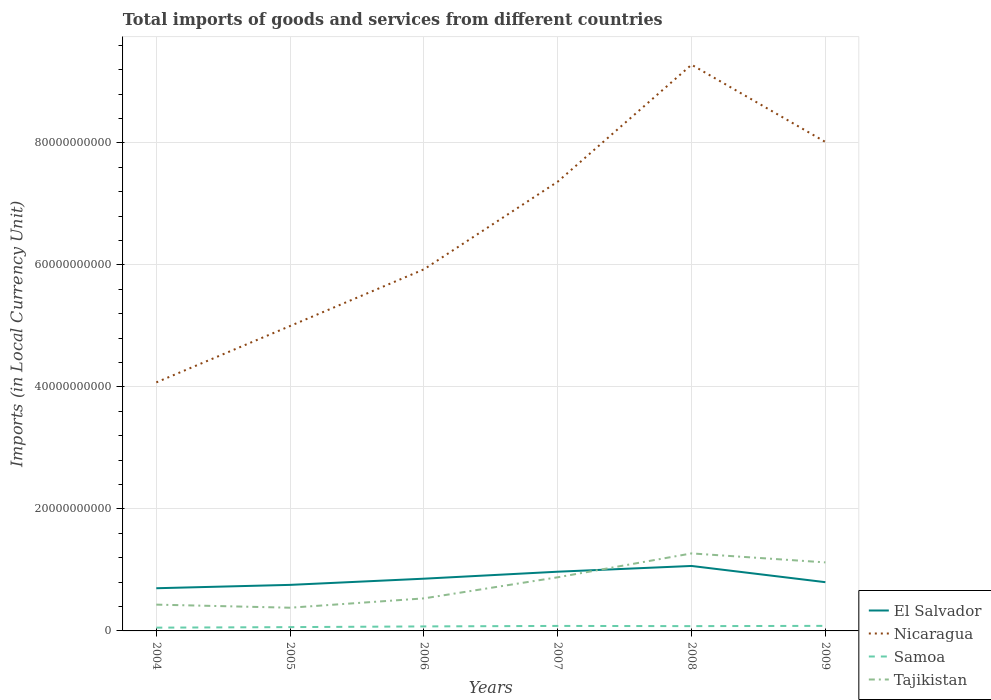How many different coloured lines are there?
Your answer should be very brief. 4. Does the line corresponding to El Salvador intersect with the line corresponding to Samoa?
Your answer should be compact. No. Across all years, what is the maximum Amount of goods and services imports in Nicaragua?
Keep it short and to the point. 4.07e+1. What is the total Amount of goods and services imports in Nicaragua in the graph?
Your response must be concise. -3.29e+1. What is the difference between the highest and the second highest Amount of goods and services imports in Samoa?
Offer a terse response. 2.92e+08. Is the Amount of goods and services imports in Samoa strictly greater than the Amount of goods and services imports in El Salvador over the years?
Give a very brief answer. Yes. What is the difference between two consecutive major ticks on the Y-axis?
Give a very brief answer. 2.00e+1. Does the graph contain any zero values?
Provide a short and direct response. No. How many legend labels are there?
Provide a short and direct response. 4. How are the legend labels stacked?
Keep it short and to the point. Vertical. What is the title of the graph?
Keep it short and to the point. Total imports of goods and services from different countries. What is the label or title of the Y-axis?
Ensure brevity in your answer.  Imports (in Local Currency Unit). What is the Imports (in Local Currency Unit) in El Salvador in 2004?
Make the answer very short. 7.00e+09. What is the Imports (in Local Currency Unit) in Nicaragua in 2004?
Your answer should be compact. 4.07e+1. What is the Imports (in Local Currency Unit) in Samoa in 2004?
Your answer should be very brief. 5.37e+08. What is the Imports (in Local Currency Unit) in Tajikistan in 2004?
Offer a very short reply. 4.31e+09. What is the Imports (in Local Currency Unit) in El Salvador in 2005?
Make the answer very short. 7.55e+09. What is the Imports (in Local Currency Unit) in Nicaragua in 2005?
Ensure brevity in your answer.  5.00e+1. What is the Imports (in Local Currency Unit) of Samoa in 2005?
Keep it short and to the point. 6.23e+08. What is the Imports (in Local Currency Unit) in Tajikistan in 2005?
Give a very brief answer. 3.81e+09. What is the Imports (in Local Currency Unit) of El Salvador in 2006?
Your answer should be very brief. 8.56e+09. What is the Imports (in Local Currency Unit) of Nicaragua in 2006?
Provide a succinct answer. 5.93e+1. What is the Imports (in Local Currency Unit) of Samoa in 2006?
Give a very brief answer. 7.39e+08. What is the Imports (in Local Currency Unit) of Tajikistan in 2006?
Make the answer very short. 5.34e+09. What is the Imports (in Local Currency Unit) of El Salvador in 2007?
Offer a very short reply. 9.71e+09. What is the Imports (in Local Currency Unit) in Nicaragua in 2007?
Keep it short and to the point. 7.37e+1. What is the Imports (in Local Currency Unit) in Samoa in 2007?
Offer a very short reply. 8.20e+08. What is the Imports (in Local Currency Unit) of Tajikistan in 2007?
Provide a succinct answer. 8.79e+09. What is the Imports (in Local Currency Unit) in El Salvador in 2008?
Give a very brief answer. 1.07e+1. What is the Imports (in Local Currency Unit) of Nicaragua in 2008?
Your answer should be very brief. 9.28e+1. What is the Imports (in Local Currency Unit) of Samoa in 2008?
Provide a short and direct response. 7.86e+08. What is the Imports (in Local Currency Unit) in Tajikistan in 2008?
Give a very brief answer. 1.27e+1. What is the Imports (in Local Currency Unit) in El Salvador in 2009?
Keep it short and to the point. 7.99e+09. What is the Imports (in Local Currency Unit) in Nicaragua in 2009?
Your response must be concise. 8.02e+1. What is the Imports (in Local Currency Unit) of Samoa in 2009?
Offer a terse response. 8.29e+08. What is the Imports (in Local Currency Unit) of Tajikistan in 2009?
Keep it short and to the point. 1.12e+1. Across all years, what is the maximum Imports (in Local Currency Unit) of El Salvador?
Keep it short and to the point. 1.07e+1. Across all years, what is the maximum Imports (in Local Currency Unit) of Nicaragua?
Offer a very short reply. 9.28e+1. Across all years, what is the maximum Imports (in Local Currency Unit) of Samoa?
Offer a very short reply. 8.29e+08. Across all years, what is the maximum Imports (in Local Currency Unit) in Tajikistan?
Keep it short and to the point. 1.27e+1. Across all years, what is the minimum Imports (in Local Currency Unit) of El Salvador?
Ensure brevity in your answer.  7.00e+09. Across all years, what is the minimum Imports (in Local Currency Unit) in Nicaragua?
Ensure brevity in your answer.  4.07e+1. Across all years, what is the minimum Imports (in Local Currency Unit) in Samoa?
Offer a terse response. 5.37e+08. Across all years, what is the minimum Imports (in Local Currency Unit) in Tajikistan?
Your answer should be compact. 3.81e+09. What is the total Imports (in Local Currency Unit) of El Salvador in the graph?
Make the answer very short. 5.15e+1. What is the total Imports (in Local Currency Unit) in Nicaragua in the graph?
Offer a terse response. 3.97e+11. What is the total Imports (in Local Currency Unit) of Samoa in the graph?
Provide a short and direct response. 4.33e+09. What is the total Imports (in Local Currency Unit) in Tajikistan in the graph?
Offer a very short reply. 4.62e+1. What is the difference between the Imports (in Local Currency Unit) in El Salvador in 2004 and that in 2005?
Make the answer very short. -5.51e+08. What is the difference between the Imports (in Local Currency Unit) of Nicaragua in 2004 and that in 2005?
Make the answer very short. -9.25e+09. What is the difference between the Imports (in Local Currency Unit) of Samoa in 2004 and that in 2005?
Ensure brevity in your answer.  -8.63e+07. What is the difference between the Imports (in Local Currency Unit) of Tajikistan in 2004 and that in 2005?
Keep it short and to the point. 5.06e+08. What is the difference between the Imports (in Local Currency Unit) of El Salvador in 2004 and that in 2006?
Make the answer very short. -1.57e+09. What is the difference between the Imports (in Local Currency Unit) in Nicaragua in 2004 and that in 2006?
Offer a terse response. -1.85e+1. What is the difference between the Imports (in Local Currency Unit) in Samoa in 2004 and that in 2006?
Ensure brevity in your answer.  -2.02e+08. What is the difference between the Imports (in Local Currency Unit) in Tajikistan in 2004 and that in 2006?
Your response must be concise. -1.02e+09. What is the difference between the Imports (in Local Currency Unit) in El Salvador in 2004 and that in 2007?
Make the answer very short. -2.71e+09. What is the difference between the Imports (in Local Currency Unit) of Nicaragua in 2004 and that in 2007?
Give a very brief answer. -3.29e+1. What is the difference between the Imports (in Local Currency Unit) in Samoa in 2004 and that in 2007?
Your answer should be very brief. -2.83e+08. What is the difference between the Imports (in Local Currency Unit) in Tajikistan in 2004 and that in 2007?
Make the answer very short. -4.48e+09. What is the difference between the Imports (in Local Currency Unit) of El Salvador in 2004 and that in 2008?
Provide a succinct answer. -3.65e+09. What is the difference between the Imports (in Local Currency Unit) in Nicaragua in 2004 and that in 2008?
Give a very brief answer. -5.21e+1. What is the difference between the Imports (in Local Currency Unit) of Samoa in 2004 and that in 2008?
Offer a terse response. -2.49e+08. What is the difference between the Imports (in Local Currency Unit) in Tajikistan in 2004 and that in 2008?
Provide a short and direct response. -8.40e+09. What is the difference between the Imports (in Local Currency Unit) of El Salvador in 2004 and that in 2009?
Provide a succinct answer. -9.92e+08. What is the difference between the Imports (in Local Currency Unit) of Nicaragua in 2004 and that in 2009?
Your answer should be very brief. -3.94e+1. What is the difference between the Imports (in Local Currency Unit) of Samoa in 2004 and that in 2009?
Provide a succinct answer. -2.92e+08. What is the difference between the Imports (in Local Currency Unit) in Tajikistan in 2004 and that in 2009?
Make the answer very short. -6.92e+09. What is the difference between the Imports (in Local Currency Unit) of El Salvador in 2005 and that in 2006?
Your answer should be compact. -1.02e+09. What is the difference between the Imports (in Local Currency Unit) of Nicaragua in 2005 and that in 2006?
Provide a short and direct response. -9.29e+09. What is the difference between the Imports (in Local Currency Unit) of Samoa in 2005 and that in 2006?
Your response must be concise. -1.16e+08. What is the difference between the Imports (in Local Currency Unit) in Tajikistan in 2005 and that in 2006?
Offer a very short reply. -1.53e+09. What is the difference between the Imports (in Local Currency Unit) of El Salvador in 2005 and that in 2007?
Make the answer very short. -2.16e+09. What is the difference between the Imports (in Local Currency Unit) in Nicaragua in 2005 and that in 2007?
Your answer should be compact. -2.37e+1. What is the difference between the Imports (in Local Currency Unit) of Samoa in 2005 and that in 2007?
Keep it short and to the point. -1.97e+08. What is the difference between the Imports (in Local Currency Unit) in Tajikistan in 2005 and that in 2007?
Provide a succinct answer. -4.99e+09. What is the difference between the Imports (in Local Currency Unit) in El Salvador in 2005 and that in 2008?
Offer a very short reply. -3.10e+09. What is the difference between the Imports (in Local Currency Unit) in Nicaragua in 2005 and that in 2008?
Ensure brevity in your answer.  -4.28e+1. What is the difference between the Imports (in Local Currency Unit) of Samoa in 2005 and that in 2008?
Give a very brief answer. -1.63e+08. What is the difference between the Imports (in Local Currency Unit) in Tajikistan in 2005 and that in 2008?
Provide a succinct answer. -8.90e+09. What is the difference between the Imports (in Local Currency Unit) in El Salvador in 2005 and that in 2009?
Your answer should be compact. -4.42e+08. What is the difference between the Imports (in Local Currency Unit) in Nicaragua in 2005 and that in 2009?
Ensure brevity in your answer.  -3.02e+1. What is the difference between the Imports (in Local Currency Unit) in Samoa in 2005 and that in 2009?
Your answer should be compact. -2.06e+08. What is the difference between the Imports (in Local Currency Unit) of Tajikistan in 2005 and that in 2009?
Your answer should be very brief. -7.43e+09. What is the difference between the Imports (in Local Currency Unit) in El Salvador in 2006 and that in 2007?
Ensure brevity in your answer.  -1.15e+09. What is the difference between the Imports (in Local Currency Unit) in Nicaragua in 2006 and that in 2007?
Keep it short and to the point. -1.44e+1. What is the difference between the Imports (in Local Currency Unit) in Samoa in 2006 and that in 2007?
Make the answer very short. -8.07e+07. What is the difference between the Imports (in Local Currency Unit) in Tajikistan in 2006 and that in 2007?
Offer a terse response. -3.46e+09. What is the difference between the Imports (in Local Currency Unit) in El Salvador in 2006 and that in 2008?
Provide a succinct answer. -2.09e+09. What is the difference between the Imports (in Local Currency Unit) in Nicaragua in 2006 and that in 2008?
Your answer should be compact. -3.35e+1. What is the difference between the Imports (in Local Currency Unit) of Samoa in 2006 and that in 2008?
Ensure brevity in your answer.  -4.67e+07. What is the difference between the Imports (in Local Currency Unit) in Tajikistan in 2006 and that in 2008?
Ensure brevity in your answer.  -7.37e+09. What is the difference between the Imports (in Local Currency Unit) of El Salvador in 2006 and that in 2009?
Offer a very short reply. 5.74e+08. What is the difference between the Imports (in Local Currency Unit) in Nicaragua in 2006 and that in 2009?
Provide a short and direct response. -2.09e+1. What is the difference between the Imports (in Local Currency Unit) in Samoa in 2006 and that in 2009?
Provide a succinct answer. -8.99e+07. What is the difference between the Imports (in Local Currency Unit) of Tajikistan in 2006 and that in 2009?
Offer a very short reply. -5.90e+09. What is the difference between the Imports (in Local Currency Unit) in El Salvador in 2007 and that in 2008?
Provide a short and direct response. -9.41e+08. What is the difference between the Imports (in Local Currency Unit) in Nicaragua in 2007 and that in 2008?
Offer a very short reply. -1.92e+1. What is the difference between the Imports (in Local Currency Unit) in Samoa in 2007 and that in 2008?
Make the answer very short. 3.40e+07. What is the difference between the Imports (in Local Currency Unit) in Tajikistan in 2007 and that in 2008?
Your answer should be very brief. -3.91e+09. What is the difference between the Imports (in Local Currency Unit) of El Salvador in 2007 and that in 2009?
Offer a terse response. 1.72e+09. What is the difference between the Imports (in Local Currency Unit) of Nicaragua in 2007 and that in 2009?
Provide a short and direct response. -6.51e+09. What is the difference between the Imports (in Local Currency Unit) of Samoa in 2007 and that in 2009?
Your answer should be compact. -9.19e+06. What is the difference between the Imports (in Local Currency Unit) of Tajikistan in 2007 and that in 2009?
Offer a very short reply. -2.44e+09. What is the difference between the Imports (in Local Currency Unit) of El Salvador in 2008 and that in 2009?
Your answer should be compact. 2.66e+09. What is the difference between the Imports (in Local Currency Unit) of Nicaragua in 2008 and that in 2009?
Offer a very short reply. 1.27e+1. What is the difference between the Imports (in Local Currency Unit) in Samoa in 2008 and that in 2009?
Provide a short and direct response. -4.32e+07. What is the difference between the Imports (in Local Currency Unit) of Tajikistan in 2008 and that in 2009?
Provide a short and direct response. 1.47e+09. What is the difference between the Imports (in Local Currency Unit) of El Salvador in 2004 and the Imports (in Local Currency Unit) of Nicaragua in 2005?
Offer a terse response. -4.30e+1. What is the difference between the Imports (in Local Currency Unit) in El Salvador in 2004 and the Imports (in Local Currency Unit) in Samoa in 2005?
Offer a very short reply. 6.38e+09. What is the difference between the Imports (in Local Currency Unit) in El Salvador in 2004 and the Imports (in Local Currency Unit) in Tajikistan in 2005?
Your answer should be compact. 3.19e+09. What is the difference between the Imports (in Local Currency Unit) of Nicaragua in 2004 and the Imports (in Local Currency Unit) of Samoa in 2005?
Your answer should be very brief. 4.01e+1. What is the difference between the Imports (in Local Currency Unit) in Nicaragua in 2004 and the Imports (in Local Currency Unit) in Tajikistan in 2005?
Your response must be concise. 3.69e+1. What is the difference between the Imports (in Local Currency Unit) in Samoa in 2004 and the Imports (in Local Currency Unit) in Tajikistan in 2005?
Make the answer very short. -3.27e+09. What is the difference between the Imports (in Local Currency Unit) of El Salvador in 2004 and the Imports (in Local Currency Unit) of Nicaragua in 2006?
Your response must be concise. -5.23e+1. What is the difference between the Imports (in Local Currency Unit) of El Salvador in 2004 and the Imports (in Local Currency Unit) of Samoa in 2006?
Give a very brief answer. 6.26e+09. What is the difference between the Imports (in Local Currency Unit) in El Salvador in 2004 and the Imports (in Local Currency Unit) in Tajikistan in 2006?
Provide a short and direct response. 1.66e+09. What is the difference between the Imports (in Local Currency Unit) in Nicaragua in 2004 and the Imports (in Local Currency Unit) in Samoa in 2006?
Offer a terse response. 4.00e+1. What is the difference between the Imports (in Local Currency Unit) of Nicaragua in 2004 and the Imports (in Local Currency Unit) of Tajikistan in 2006?
Offer a very short reply. 3.54e+1. What is the difference between the Imports (in Local Currency Unit) in Samoa in 2004 and the Imports (in Local Currency Unit) in Tajikistan in 2006?
Offer a terse response. -4.80e+09. What is the difference between the Imports (in Local Currency Unit) of El Salvador in 2004 and the Imports (in Local Currency Unit) of Nicaragua in 2007?
Ensure brevity in your answer.  -6.67e+1. What is the difference between the Imports (in Local Currency Unit) in El Salvador in 2004 and the Imports (in Local Currency Unit) in Samoa in 2007?
Offer a very short reply. 6.18e+09. What is the difference between the Imports (in Local Currency Unit) in El Salvador in 2004 and the Imports (in Local Currency Unit) in Tajikistan in 2007?
Offer a terse response. -1.80e+09. What is the difference between the Imports (in Local Currency Unit) of Nicaragua in 2004 and the Imports (in Local Currency Unit) of Samoa in 2007?
Make the answer very short. 3.99e+1. What is the difference between the Imports (in Local Currency Unit) in Nicaragua in 2004 and the Imports (in Local Currency Unit) in Tajikistan in 2007?
Give a very brief answer. 3.20e+1. What is the difference between the Imports (in Local Currency Unit) of Samoa in 2004 and the Imports (in Local Currency Unit) of Tajikistan in 2007?
Make the answer very short. -8.26e+09. What is the difference between the Imports (in Local Currency Unit) in El Salvador in 2004 and the Imports (in Local Currency Unit) in Nicaragua in 2008?
Keep it short and to the point. -8.58e+1. What is the difference between the Imports (in Local Currency Unit) of El Salvador in 2004 and the Imports (in Local Currency Unit) of Samoa in 2008?
Ensure brevity in your answer.  6.21e+09. What is the difference between the Imports (in Local Currency Unit) in El Salvador in 2004 and the Imports (in Local Currency Unit) in Tajikistan in 2008?
Offer a very short reply. -5.71e+09. What is the difference between the Imports (in Local Currency Unit) of Nicaragua in 2004 and the Imports (in Local Currency Unit) of Samoa in 2008?
Provide a short and direct response. 4.00e+1. What is the difference between the Imports (in Local Currency Unit) in Nicaragua in 2004 and the Imports (in Local Currency Unit) in Tajikistan in 2008?
Your response must be concise. 2.80e+1. What is the difference between the Imports (in Local Currency Unit) in Samoa in 2004 and the Imports (in Local Currency Unit) in Tajikistan in 2008?
Keep it short and to the point. -1.22e+1. What is the difference between the Imports (in Local Currency Unit) of El Salvador in 2004 and the Imports (in Local Currency Unit) of Nicaragua in 2009?
Provide a short and direct response. -7.32e+1. What is the difference between the Imports (in Local Currency Unit) in El Salvador in 2004 and the Imports (in Local Currency Unit) in Samoa in 2009?
Offer a terse response. 6.17e+09. What is the difference between the Imports (in Local Currency Unit) of El Salvador in 2004 and the Imports (in Local Currency Unit) of Tajikistan in 2009?
Offer a terse response. -4.24e+09. What is the difference between the Imports (in Local Currency Unit) in Nicaragua in 2004 and the Imports (in Local Currency Unit) in Samoa in 2009?
Provide a succinct answer. 3.99e+1. What is the difference between the Imports (in Local Currency Unit) of Nicaragua in 2004 and the Imports (in Local Currency Unit) of Tajikistan in 2009?
Your answer should be compact. 2.95e+1. What is the difference between the Imports (in Local Currency Unit) of Samoa in 2004 and the Imports (in Local Currency Unit) of Tajikistan in 2009?
Your response must be concise. -1.07e+1. What is the difference between the Imports (in Local Currency Unit) in El Salvador in 2005 and the Imports (in Local Currency Unit) in Nicaragua in 2006?
Offer a terse response. -5.17e+1. What is the difference between the Imports (in Local Currency Unit) of El Salvador in 2005 and the Imports (in Local Currency Unit) of Samoa in 2006?
Your answer should be compact. 6.81e+09. What is the difference between the Imports (in Local Currency Unit) of El Salvador in 2005 and the Imports (in Local Currency Unit) of Tajikistan in 2006?
Your answer should be very brief. 2.21e+09. What is the difference between the Imports (in Local Currency Unit) in Nicaragua in 2005 and the Imports (in Local Currency Unit) in Samoa in 2006?
Your answer should be very brief. 4.93e+1. What is the difference between the Imports (in Local Currency Unit) in Nicaragua in 2005 and the Imports (in Local Currency Unit) in Tajikistan in 2006?
Your answer should be very brief. 4.47e+1. What is the difference between the Imports (in Local Currency Unit) of Samoa in 2005 and the Imports (in Local Currency Unit) of Tajikistan in 2006?
Provide a succinct answer. -4.71e+09. What is the difference between the Imports (in Local Currency Unit) of El Salvador in 2005 and the Imports (in Local Currency Unit) of Nicaragua in 2007?
Offer a very short reply. -6.61e+1. What is the difference between the Imports (in Local Currency Unit) in El Salvador in 2005 and the Imports (in Local Currency Unit) in Samoa in 2007?
Provide a succinct answer. 6.73e+09. What is the difference between the Imports (in Local Currency Unit) of El Salvador in 2005 and the Imports (in Local Currency Unit) of Tajikistan in 2007?
Keep it short and to the point. -1.25e+09. What is the difference between the Imports (in Local Currency Unit) of Nicaragua in 2005 and the Imports (in Local Currency Unit) of Samoa in 2007?
Ensure brevity in your answer.  4.92e+1. What is the difference between the Imports (in Local Currency Unit) of Nicaragua in 2005 and the Imports (in Local Currency Unit) of Tajikistan in 2007?
Your response must be concise. 4.12e+1. What is the difference between the Imports (in Local Currency Unit) of Samoa in 2005 and the Imports (in Local Currency Unit) of Tajikistan in 2007?
Provide a short and direct response. -8.17e+09. What is the difference between the Imports (in Local Currency Unit) of El Salvador in 2005 and the Imports (in Local Currency Unit) of Nicaragua in 2008?
Provide a succinct answer. -8.53e+1. What is the difference between the Imports (in Local Currency Unit) of El Salvador in 2005 and the Imports (in Local Currency Unit) of Samoa in 2008?
Your answer should be very brief. 6.76e+09. What is the difference between the Imports (in Local Currency Unit) of El Salvador in 2005 and the Imports (in Local Currency Unit) of Tajikistan in 2008?
Your response must be concise. -5.16e+09. What is the difference between the Imports (in Local Currency Unit) of Nicaragua in 2005 and the Imports (in Local Currency Unit) of Samoa in 2008?
Provide a short and direct response. 4.92e+1. What is the difference between the Imports (in Local Currency Unit) of Nicaragua in 2005 and the Imports (in Local Currency Unit) of Tajikistan in 2008?
Your response must be concise. 3.73e+1. What is the difference between the Imports (in Local Currency Unit) of Samoa in 2005 and the Imports (in Local Currency Unit) of Tajikistan in 2008?
Keep it short and to the point. -1.21e+1. What is the difference between the Imports (in Local Currency Unit) of El Salvador in 2005 and the Imports (in Local Currency Unit) of Nicaragua in 2009?
Offer a terse response. -7.26e+1. What is the difference between the Imports (in Local Currency Unit) of El Salvador in 2005 and the Imports (in Local Currency Unit) of Samoa in 2009?
Keep it short and to the point. 6.72e+09. What is the difference between the Imports (in Local Currency Unit) of El Salvador in 2005 and the Imports (in Local Currency Unit) of Tajikistan in 2009?
Keep it short and to the point. -3.69e+09. What is the difference between the Imports (in Local Currency Unit) of Nicaragua in 2005 and the Imports (in Local Currency Unit) of Samoa in 2009?
Keep it short and to the point. 4.92e+1. What is the difference between the Imports (in Local Currency Unit) of Nicaragua in 2005 and the Imports (in Local Currency Unit) of Tajikistan in 2009?
Give a very brief answer. 3.88e+1. What is the difference between the Imports (in Local Currency Unit) of Samoa in 2005 and the Imports (in Local Currency Unit) of Tajikistan in 2009?
Your response must be concise. -1.06e+1. What is the difference between the Imports (in Local Currency Unit) of El Salvador in 2006 and the Imports (in Local Currency Unit) of Nicaragua in 2007?
Keep it short and to the point. -6.51e+1. What is the difference between the Imports (in Local Currency Unit) in El Salvador in 2006 and the Imports (in Local Currency Unit) in Samoa in 2007?
Make the answer very short. 7.74e+09. What is the difference between the Imports (in Local Currency Unit) of El Salvador in 2006 and the Imports (in Local Currency Unit) of Tajikistan in 2007?
Make the answer very short. -2.31e+08. What is the difference between the Imports (in Local Currency Unit) of Nicaragua in 2006 and the Imports (in Local Currency Unit) of Samoa in 2007?
Your answer should be compact. 5.85e+1. What is the difference between the Imports (in Local Currency Unit) in Nicaragua in 2006 and the Imports (in Local Currency Unit) in Tajikistan in 2007?
Your answer should be compact. 5.05e+1. What is the difference between the Imports (in Local Currency Unit) of Samoa in 2006 and the Imports (in Local Currency Unit) of Tajikistan in 2007?
Your answer should be compact. -8.06e+09. What is the difference between the Imports (in Local Currency Unit) of El Salvador in 2006 and the Imports (in Local Currency Unit) of Nicaragua in 2008?
Offer a terse response. -8.43e+1. What is the difference between the Imports (in Local Currency Unit) of El Salvador in 2006 and the Imports (in Local Currency Unit) of Samoa in 2008?
Ensure brevity in your answer.  7.78e+09. What is the difference between the Imports (in Local Currency Unit) of El Salvador in 2006 and the Imports (in Local Currency Unit) of Tajikistan in 2008?
Your response must be concise. -4.14e+09. What is the difference between the Imports (in Local Currency Unit) in Nicaragua in 2006 and the Imports (in Local Currency Unit) in Samoa in 2008?
Provide a succinct answer. 5.85e+1. What is the difference between the Imports (in Local Currency Unit) of Nicaragua in 2006 and the Imports (in Local Currency Unit) of Tajikistan in 2008?
Offer a terse response. 4.66e+1. What is the difference between the Imports (in Local Currency Unit) in Samoa in 2006 and the Imports (in Local Currency Unit) in Tajikistan in 2008?
Provide a succinct answer. -1.20e+1. What is the difference between the Imports (in Local Currency Unit) of El Salvador in 2006 and the Imports (in Local Currency Unit) of Nicaragua in 2009?
Provide a succinct answer. -7.16e+1. What is the difference between the Imports (in Local Currency Unit) in El Salvador in 2006 and the Imports (in Local Currency Unit) in Samoa in 2009?
Make the answer very short. 7.74e+09. What is the difference between the Imports (in Local Currency Unit) in El Salvador in 2006 and the Imports (in Local Currency Unit) in Tajikistan in 2009?
Your answer should be compact. -2.67e+09. What is the difference between the Imports (in Local Currency Unit) of Nicaragua in 2006 and the Imports (in Local Currency Unit) of Samoa in 2009?
Offer a terse response. 5.85e+1. What is the difference between the Imports (in Local Currency Unit) of Nicaragua in 2006 and the Imports (in Local Currency Unit) of Tajikistan in 2009?
Make the answer very short. 4.80e+1. What is the difference between the Imports (in Local Currency Unit) of Samoa in 2006 and the Imports (in Local Currency Unit) of Tajikistan in 2009?
Offer a terse response. -1.05e+1. What is the difference between the Imports (in Local Currency Unit) of El Salvador in 2007 and the Imports (in Local Currency Unit) of Nicaragua in 2008?
Give a very brief answer. -8.31e+1. What is the difference between the Imports (in Local Currency Unit) of El Salvador in 2007 and the Imports (in Local Currency Unit) of Samoa in 2008?
Ensure brevity in your answer.  8.92e+09. What is the difference between the Imports (in Local Currency Unit) in El Salvador in 2007 and the Imports (in Local Currency Unit) in Tajikistan in 2008?
Provide a short and direct response. -3.00e+09. What is the difference between the Imports (in Local Currency Unit) of Nicaragua in 2007 and the Imports (in Local Currency Unit) of Samoa in 2008?
Your response must be concise. 7.29e+1. What is the difference between the Imports (in Local Currency Unit) of Nicaragua in 2007 and the Imports (in Local Currency Unit) of Tajikistan in 2008?
Ensure brevity in your answer.  6.10e+1. What is the difference between the Imports (in Local Currency Unit) of Samoa in 2007 and the Imports (in Local Currency Unit) of Tajikistan in 2008?
Your response must be concise. -1.19e+1. What is the difference between the Imports (in Local Currency Unit) in El Salvador in 2007 and the Imports (in Local Currency Unit) in Nicaragua in 2009?
Ensure brevity in your answer.  -7.05e+1. What is the difference between the Imports (in Local Currency Unit) of El Salvador in 2007 and the Imports (in Local Currency Unit) of Samoa in 2009?
Offer a very short reply. 8.88e+09. What is the difference between the Imports (in Local Currency Unit) of El Salvador in 2007 and the Imports (in Local Currency Unit) of Tajikistan in 2009?
Provide a short and direct response. -1.53e+09. What is the difference between the Imports (in Local Currency Unit) of Nicaragua in 2007 and the Imports (in Local Currency Unit) of Samoa in 2009?
Give a very brief answer. 7.28e+1. What is the difference between the Imports (in Local Currency Unit) in Nicaragua in 2007 and the Imports (in Local Currency Unit) in Tajikistan in 2009?
Make the answer very short. 6.24e+1. What is the difference between the Imports (in Local Currency Unit) of Samoa in 2007 and the Imports (in Local Currency Unit) of Tajikistan in 2009?
Your response must be concise. -1.04e+1. What is the difference between the Imports (in Local Currency Unit) of El Salvador in 2008 and the Imports (in Local Currency Unit) of Nicaragua in 2009?
Your answer should be compact. -6.95e+1. What is the difference between the Imports (in Local Currency Unit) of El Salvador in 2008 and the Imports (in Local Currency Unit) of Samoa in 2009?
Your answer should be compact. 9.82e+09. What is the difference between the Imports (in Local Currency Unit) of El Salvador in 2008 and the Imports (in Local Currency Unit) of Tajikistan in 2009?
Keep it short and to the point. -5.85e+08. What is the difference between the Imports (in Local Currency Unit) in Nicaragua in 2008 and the Imports (in Local Currency Unit) in Samoa in 2009?
Your answer should be very brief. 9.20e+1. What is the difference between the Imports (in Local Currency Unit) in Nicaragua in 2008 and the Imports (in Local Currency Unit) in Tajikistan in 2009?
Make the answer very short. 8.16e+1. What is the difference between the Imports (in Local Currency Unit) in Samoa in 2008 and the Imports (in Local Currency Unit) in Tajikistan in 2009?
Your answer should be very brief. -1.05e+1. What is the average Imports (in Local Currency Unit) of El Salvador per year?
Offer a terse response. 8.58e+09. What is the average Imports (in Local Currency Unit) in Nicaragua per year?
Your answer should be very brief. 6.61e+1. What is the average Imports (in Local Currency Unit) of Samoa per year?
Provide a short and direct response. 7.22e+08. What is the average Imports (in Local Currency Unit) in Tajikistan per year?
Your answer should be compact. 7.70e+09. In the year 2004, what is the difference between the Imports (in Local Currency Unit) of El Salvador and Imports (in Local Currency Unit) of Nicaragua?
Provide a succinct answer. -3.37e+1. In the year 2004, what is the difference between the Imports (in Local Currency Unit) of El Salvador and Imports (in Local Currency Unit) of Samoa?
Your answer should be very brief. 6.46e+09. In the year 2004, what is the difference between the Imports (in Local Currency Unit) in El Salvador and Imports (in Local Currency Unit) in Tajikistan?
Provide a succinct answer. 2.69e+09. In the year 2004, what is the difference between the Imports (in Local Currency Unit) in Nicaragua and Imports (in Local Currency Unit) in Samoa?
Ensure brevity in your answer.  4.02e+1. In the year 2004, what is the difference between the Imports (in Local Currency Unit) in Nicaragua and Imports (in Local Currency Unit) in Tajikistan?
Your response must be concise. 3.64e+1. In the year 2004, what is the difference between the Imports (in Local Currency Unit) of Samoa and Imports (in Local Currency Unit) of Tajikistan?
Your answer should be very brief. -3.77e+09. In the year 2005, what is the difference between the Imports (in Local Currency Unit) in El Salvador and Imports (in Local Currency Unit) in Nicaragua?
Give a very brief answer. -4.24e+1. In the year 2005, what is the difference between the Imports (in Local Currency Unit) of El Salvador and Imports (in Local Currency Unit) of Samoa?
Your response must be concise. 6.93e+09. In the year 2005, what is the difference between the Imports (in Local Currency Unit) of El Salvador and Imports (in Local Currency Unit) of Tajikistan?
Provide a short and direct response. 3.74e+09. In the year 2005, what is the difference between the Imports (in Local Currency Unit) in Nicaragua and Imports (in Local Currency Unit) in Samoa?
Keep it short and to the point. 4.94e+1. In the year 2005, what is the difference between the Imports (in Local Currency Unit) in Nicaragua and Imports (in Local Currency Unit) in Tajikistan?
Keep it short and to the point. 4.62e+1. In the year 2005, what is the difference between the Imports (in Local Currency Unit) in Samoa and Imports (in Local Currency Unit) in Tajikistan?
Offer a very short reply. -3.18e+09. In the year 2006, what is the difference between the Imports (in Local Currency Unit) of El Salvador and Imports (in Local Currency Unit) of Nicaragua?
Your answer should be compact. -5.07e+1. In the year 2006, what is the difference between the Imports (in Local Currency Unit) in El Salvador and Imports (in Local Currency Unit) in Samoa?
Keep it short and to the point. 7.83e+09. In the year 2006, what is the difference between the Imports (in Local Currency Unit) in El Salvador and Imports (in Local Currency Unit) in Tajikistan?
Offer a very short reply. 3.23e+09. In the year 2006, what is the difference between the Imports (in Local Currency Unit) in Nicaragua and Imports (in Local Currency Unit) in Samoa?
Your answer should be compact. 5.85e+1. In the year 2006, what is the difference between the Imports (in Local Currency Unit) in Nicaragua and Imports (in Local Currency Unit) in Tajikistan?
Give a very brief answer. 5.39e+1. In the year 2006, what is the difference between the Imports (in Local Currency Unit) in Samoa and Imports (in Local Currency Unit) in Tajikistan?
Ensure brevity in your answer.  -4.60e+09. In the year 2007, what is the difference between the Imports (in Local Currency Unit) of El Salvador and Imports (in Local Currency Unit) of Nicaragua?
Keep it short and to the point. -6.39e+1. In the year 2007, what is the difference between the Imports (in Local Currency Unit) of El Salvador and Imports (in Local Currency Unit) of Samoa?
Give a very brief answer. 8.89e+09. In the year 2007, what is the difference between the Imports (in Local Currency Unit) of El Salvador and Imports (in Local Currency Unit) of Tajikistan?
Your answer should be very brief. 9.15e+08. In the year 2007, what is the difference between the Imports (in Local Currency Unit) in Nicaragua and Imports (in Local Currency Unit) in Samoa?
Your answer should be very brief. 7.28e+1. In the year 2007, what is the difference between the Imports (in Local Currency Unit) in Nicaragua and Imports (in Local Currency Unit) in Tajikistan?
Keep it short and to the point. 6.49e+1. In the year 2007, what is the difference between the Imports (in Local Currency Unit) of Samoa and Imports (in Local Currency Unit) of Tajikistan?
Give a very brief answer. -7.98e+09. In the year 2008, what is the difference between the Imports (in Local Currency Unit) of El Salvador and Imports (in Local Currency Unit) of Nicaragua?
Your answer should be very brief. -8.22e+1. In the year 2008, what is the difference between the Imports (in Local Currency Unit) in El Salvador and Imports (in Local Currency Unit) in Samoa?
Your answer should be very brief. 9.87e+09. In the year 2008, what is the difference between the Imports (in Local Currency Unit) in El Salvador and Imports (in Local Currency Unit) in Tajikistan?
Provide a short and direct response. -2.06e+09. In the year 2008, what is the difference between the Imports (in Local Currency Unit) of Nicaragua and Imports (in Local Currency Unit) of Samoa?
Offer a very short reply. 9.20e+1. In the year 2008, what is the difference between the Imports (in Local Currency Unit) of Nicaragua and Imports (in Local Currency Unit) of Tajikistan?
Your answer should be compact. 8.01e+1. In the year 2008, what is the difference between the Imports (in Local Currency Unit) in Samoa and Imports (in Local Currency Unit) in Tajikistan?
Your answer should be very brief. -1.19e+1. In the year 2009, what is the difference between the Imports (in Local Currency Unit) of El Salvador and Imports (in Local Currency Unit) of Nicaragua?
Your answer should be very brief. -7.22e+1. In the year 2009, what is the difference between the Imports (in Local Currency Unit) of El Salvador and Imports (in Local Currency Unit) of Samoa?
Keep it short and to the point. 7.16e+09. In the year 2009, what is the difference between the Imports (in Local Currency Unit) in El Salvador and Imports (in Local Currency Unit) in Tajikistan?
Provide a short and direct response. -3.25e+09. In the year 2009, what is the difference between the Imports (in Local Currency Unit) in Nicaragua and Imports (in Local Currency Unit) in Samoa?
Your answer should be very brief. 7.93e+1. In the year 2009, what is the difference between the Imports (in Local Currency Unit) of Nicaragua and Imports (in Local Currency Unit) of Tajikistan?
Provide a succinct answer. 6.89e+1. In the year 2009, what is the difference between the Imports (in Local Currency Unit) of Samoa and Imports (in Local Currency Unit) of Tajikistan?
Make the answer very short. -1.04e+1. What is the ratio of the Imports (in Local Currency Unit) of El Salvador in 2004 to that in 2005?
Make the answer very short. 0.93. What is the ratio of the Imports (in Local Currency Unit) in Nicaragua in 2004 to that in 2005?
Provide a succinct answer. 0.81. What is the ratio of the Imports (in Local Currency Unit) of Samoa in 2004 to that in 2005?
Your answer should be very brief. 0.86. What is the ratio of the Imports (in Local Currency Unit) in Tajikistan in 2004 to that in 2005?
Keep it short and to the point. 1.13. What is the ratio of the Imports (in Local Currency Unit) in El Salvador in 2004 to that in 2006?
Provide a short and direct response. 0.82. What is the ratio of the Imports (in Local Currency Unit) of Nicaragua in 2004 to that in 2006?
Ensure brevity in your answer.  0.69. What is the ratio of the Imports (in Local Currency Unit) of Samoa in 2004 to that in 2006?
Your response must be concise. 0.73. What is the ratio of the Imports (in Local Currency Unit) of Tajikistan in 2004 to that in 2006?
Offer a terse response. 0.81. What is the ratio of the Imports (in Local Currency Unit) in El Salvador in 2004 to that in 2007?
Your response must be concise. 0.72. What is the ratio of the Imports (in Local Currency Unit) in Nicaragua in 2004 to that in 2007?
Make the answer very short. 0.55. What is the ratio of the Imports (in Local Currency Unit) of Samoa in 2004 to that in 2007?
Offer a terse response. 0.66. What is the ratio of the Imports (in Local Currency Unit) in Tajikistan in 2004 to that in 2007?
Your answer should be very brief. 0.49. What is the ratio of the Imports (in Local Currency Unit) in El Salvador in 2004 to that in 2008?
Make the answer very short. 0.66. What is the ratio of the Imports (in Local Currency Unit) in Nicaragua in 2004 to that in 2008?
Your answer should be very brief. 0.44. What is the ratio of the Imports (in Local Currency Unit) of Samoa in 2004 to that in 2008?
Offer a terse response. 0.68. What is the ratio of the Imports (in Local Currency Unit) in Tajikistan in 2004 to that in 2008?
Provide a short and direct response. 0.34. What is the ratio of the Imports (in Local Currency Unit) of El Salvador in 2004 to that in 2009?
Your answer should be compact. 0.88. What is the ratio of the Imports (in Local Currency Unit) of Nicaragua in 2004 to that in 2009?
Offer a terse response. 0.51. What is the ratio of the Imports (in Local Currency Unit) in Samoa in 2004 to that in 2009?
Ensure brevity in your answer.  0.65. What is the ratio of the Imports (in Local Currency Unit) of Tajikistan in 2004 to that in 2009?
Keep it short and to the point. 0.38. What is the ratio of the Imports (in Local Currency Unit) in El Salvador in 2005 to that in 2006?
Make the answer very short. 0.88. What is the ratio of the Imports (in Local Currency Unit) of Nicaragua in 2005 to that in 2006?
Provide a short and direct response. 0.84. What is the ratio of the Imports (in Local Currency Unit) of Samoa in 2005 to that in 2006?
Your answer should be very brief. 0.84. What is the ratio of the Imports (in Local Currency Unit) of Tajikistan in 2005 to that in 2006?
Provide a succinct answer. 0.71. What is the ratio of the Imports (in Local Currency Unit) of El Salvador in 2005 to that in 2007?
Keep it short and to the point. 0.78. What is the ratio of the Imports (in Local Currency Unit) in Nicaragua in 2005 to that in 2007?
Your answer should be compact. 0.68. What is the ratio of the Imports (in Local Currency Unit) in Samoa in 2005 to that in 2007?
Provide a succinct answer. 0.76. What is the ratio of the Imports (in Local Currency Unit) in Tajikistan in 2005 to that in 2007?
Keep it short and to the point. 0.43. What is the ratio of the Imports (in Local Currency Unit) of El Salvador in 2005 to that in 2008?
Make the answer very short. 0.71. What is the ratio of the Imports (in Local Currency Unit) in Nicaragua in 2005 to that in 2008?
Give a very brief answer. 0.54. What is the ratio of the Imports (in Local Currency Unit) in Samoa in 2005 to that in 2008?
Offer a terse response. 0.79. What is the ratio of the Imports (in Local Currency Unit) of Tajikistan in 2005 to that in 2008?
Keep it short and to the point. 0.3. What is the ratio of the Imports (in Local Currency Unit) of El Salvador in 2005 to that in 2009?
Your response must be concise. 0.94. What is the ratio of the Imports (in Local Currency Unit) of Nicaragua in 2005 to that in 2009?
Provide a short and direct response. 0.62. What is the ratio of the Imports (in Local Currency Unit) of Samoa in 2005 to that in 2009?
Ensure brevity in your answer.  0.75. What is the ratio of the Imports (in Local Currency Unit) in Tajikistan in 2005 to that in 2009?
Offer a very short reply. 0.34. What is the ratio of the Imports (in Local Currency Unit) of El Salvador in 2006 to that in 2007?
Your response must be concise. 0.88. What is the ratio of the Imports (in Local Currency Unit) in Nicaragua in 2006 to that in 2007?
Give a very brief answer. 0.8. What is the ratio of the Imports (in Local Currency Unit) in Samoa in 2006 to that in 2007?
Your answer should be very brief. 0.9. What is the ratio of the Imports (in Local Currency Unit) in Tajikistan in 2006 to that in 2007?
Offer a very short reply. 0.61. What is the ratio of the Imports (in Local Currency Unit) in El Salvador in 2006 to that in 2008?
Make the answer very short. 0.8. What is the ratio of the Imports (in Local Currency Unit) of Nicaragua in 2006 to that in 2008?
Offer a very short reply. 0.64. What is the ratio of the Imports (in Local Currency Unit) in Samoa in 2006 to that in 2008?
Provide a short and direct response. 0.94. What is the ratio of the Imports (in Local Currency Unit) in Tajikistan in 2006 to that in 2008?
Your answer should be very brief. 0.42. What is the ratio of the Imports (in Local Currency Unit) of El Salvador in 2006 to that in 2009?
Keep it short and to the point. 1.07. What is the ratio of the Imports (in Local Currency Unit) of Nicaragua in 2006 to that in 2009?
Ensure brevity in your answer.  0.74. What is the ratio of the Imports (in Local Currency Unit) in Samoa in 2006 to that in 2009?
Offer a terse response. 0.89. What is the ratio of the Imports (in Local Currency Unit) in Tajikistan in 2006 to that in 2009?
Ensure brevity in your answer.  0.47. What is the ratio of the Imports (in Local Currency Unit) of El Salvador in 2007 to that in 2008?
Give a very brief answer. 0.91. What is the ratio of the Imports (in Local Currency Unit) in Nicaragua in 2007 to that in 2008?
Provide a succinct answer. 0.79. What is the ratio of the Imports (in Local Currency Unit) of Samoa in 2007 to that in 2008?
Provide a short and direct response. 1.04. What is the ratio of the Imports (in Local Currency Unit) of Tajikistan in 2007 to that in 2008?
Ensure brevity in your answer.  0.69. What is the ratio of the Imports (in Local Currency Unit) of El Salvador in 2007 to that in 2009?
Your answer should be compact. 1.22. What is the ratio of the Imports (in Local Currency Unit) in Nicaragua in 2007 to that in 2009?
Your response must be concise. 0.92. What is the ratio of the Imports (in Local Currency Unit) of Samoa in 2007 to that in 2009?
Ensure brevity in your answer.  0.99. What is the ratio of the Imports (in Local Currency Unit) of Tajikistan in 2007 to that in 2009?
Provide a succinct answer. 0.78. What is the ratio of the Imports (in Local Currency Unit) of El Salvador in 2008 to that in 2009?
Make the answer very short. 1.33. What is the ratio of the Imports (in Local Currency Unit) in Nicaragua in 2008 to that in 2009?
Provide a short and direct response. 1.16. What is the ratio of the Imports (in Local Currency Unit) of Samoa in 2008 to that in 2009?
Your answer should be very brief. 0.95. What is the ratio of the Imports (in Local Currency Unit) of Tajikistan in 2008 to that in 2009?
Offer a terse response. 1.13. What is the difference between the highest and the second highest Imports (in Local Currency Unit) in El Salvador?
Make the answer very short. 9.41e+08. What is the difference between the highest and the second highest Imports (in Local Currency Unit) in Nicaragua?
Offer a terse response. 1.27e+1. What is the difference between the highest and the second highest Imports (in Local Currency Unit) of Samoa?
Offer a very short reply. 9.19e+06. What is the difference between the highest and the second highest Imports (in Local Currency Unit) in Tajikistan?
Give a very brief answer. 1.47e+09. What is the difference between the highest and the lowest Imports (in Local Currency Unit) of El Salvador?
Keep it short and to the point. 3.65e+09. What is the difference between the highest and the lowest Imports (in Local Currency Unit) in Nicaragua?
Make the answer very short. 5.21e+1. What is the difference between the highest and the lowest Imports (in Local Currency Unit) of Samoa?
Provide a short and direct response. 2.92e+08. What is the difference between the highest and the lowest Imports (in Local Currency Unit) in Tajikistan?
Offer a terse response. 8.90e+09. 